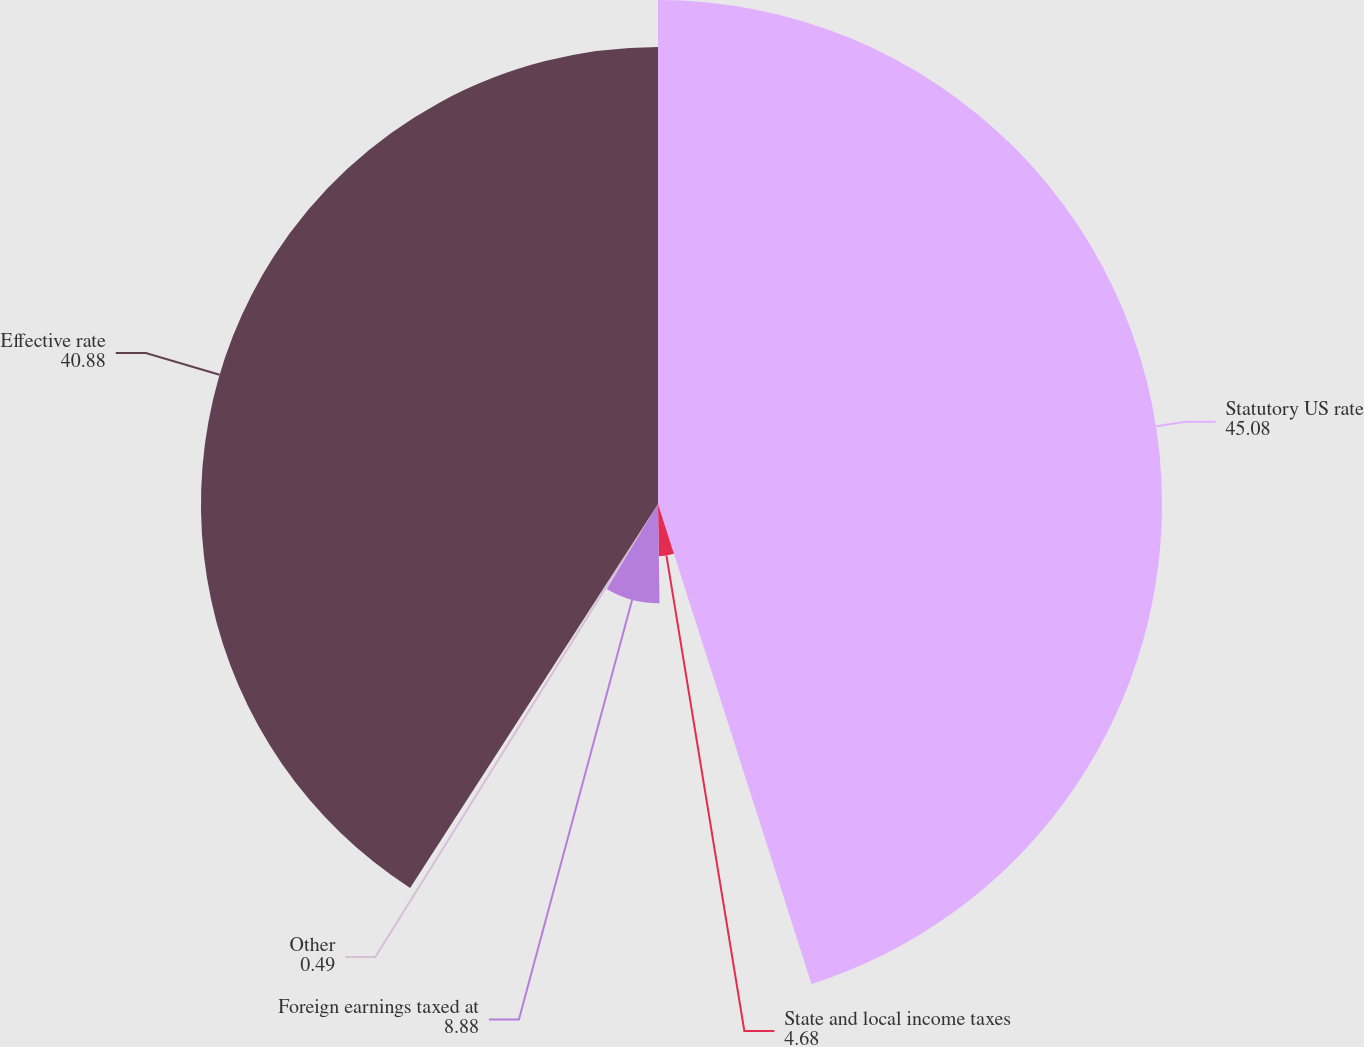<chart> <loc_0><loc_0><loc_500><loc_500><pie_chart><fcel>Statutory US rate<fcel>State and local income taxes<fcel>Foreign earnings taxed at<fcel>Other<fcel>Effective rate<nl><fcel>45.08%<fcel>4.68%<fcel>8.88%<fcel>0.49%<fcel>40.88%<nl></chart> 